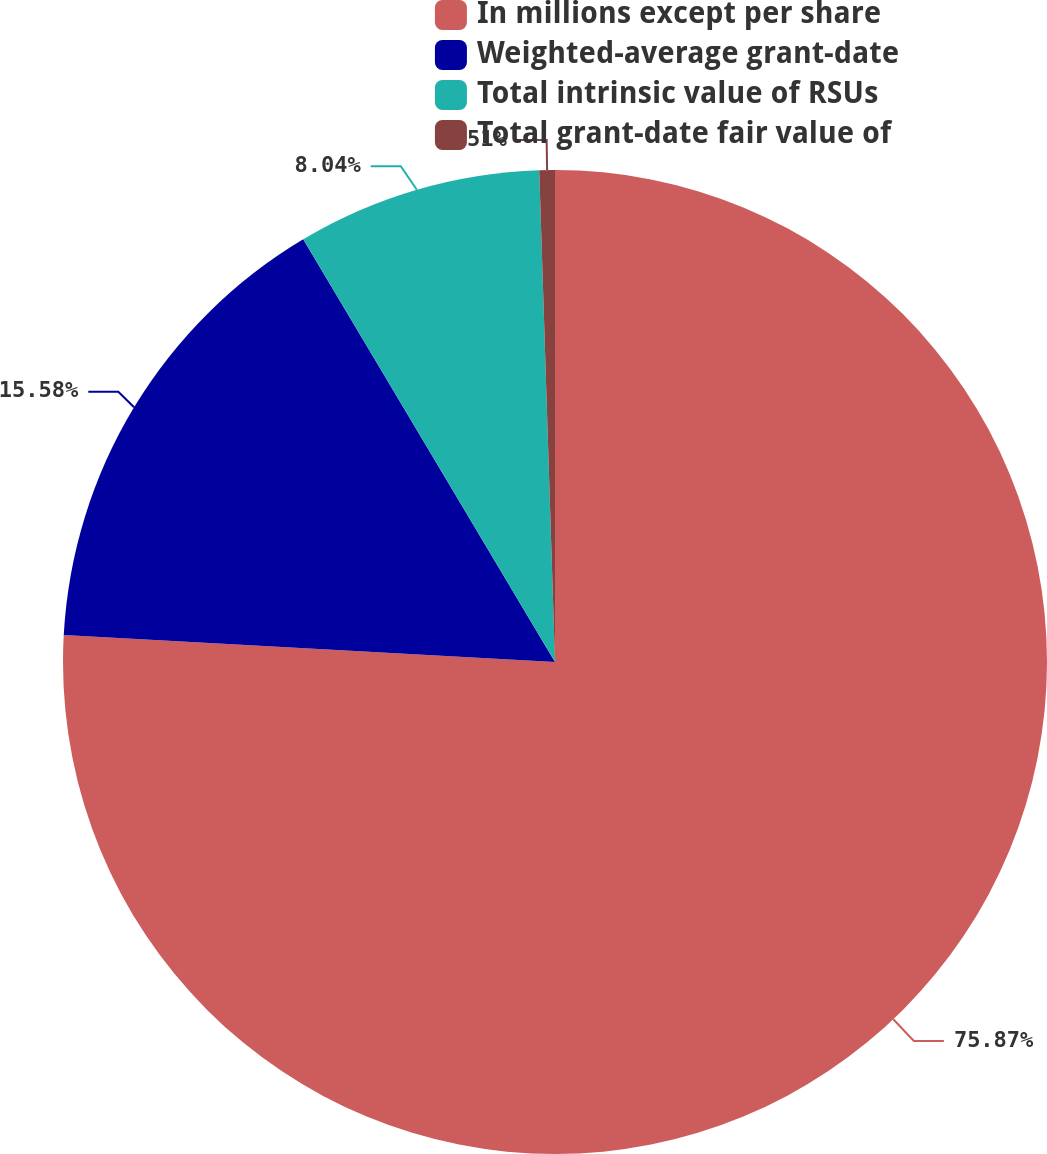<chart> <loc_0><loc_0><loc_500><loc_500><pie_chart><fcel>In millions except per share<fcel>Weighted-average grant-date<fcel>Total intrinsic value of RSUs<fcel>Total grant-date fair value of<nl><fcel>75.87%<fcel>15.58%<fcel>8.04%<fcel>0.51%<nl></chart> 